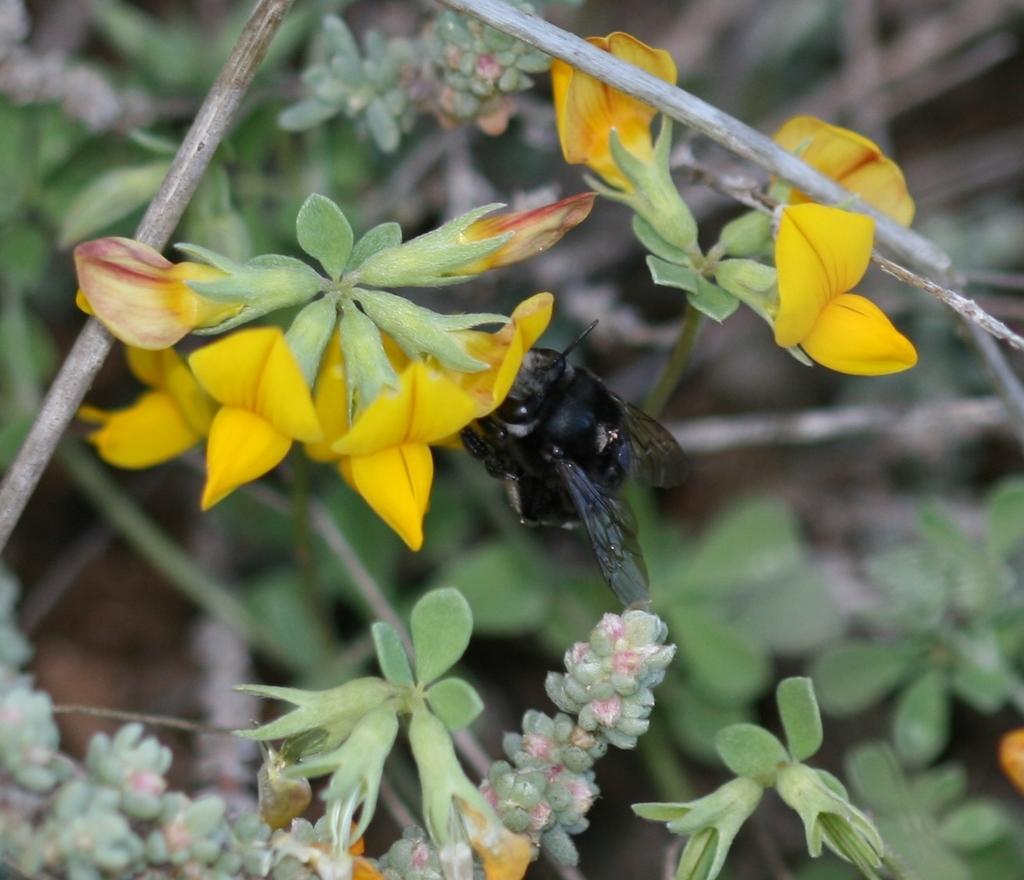Describe this image in one or two sentences. This picture shows few trees with flowers and we see a black color insect. 